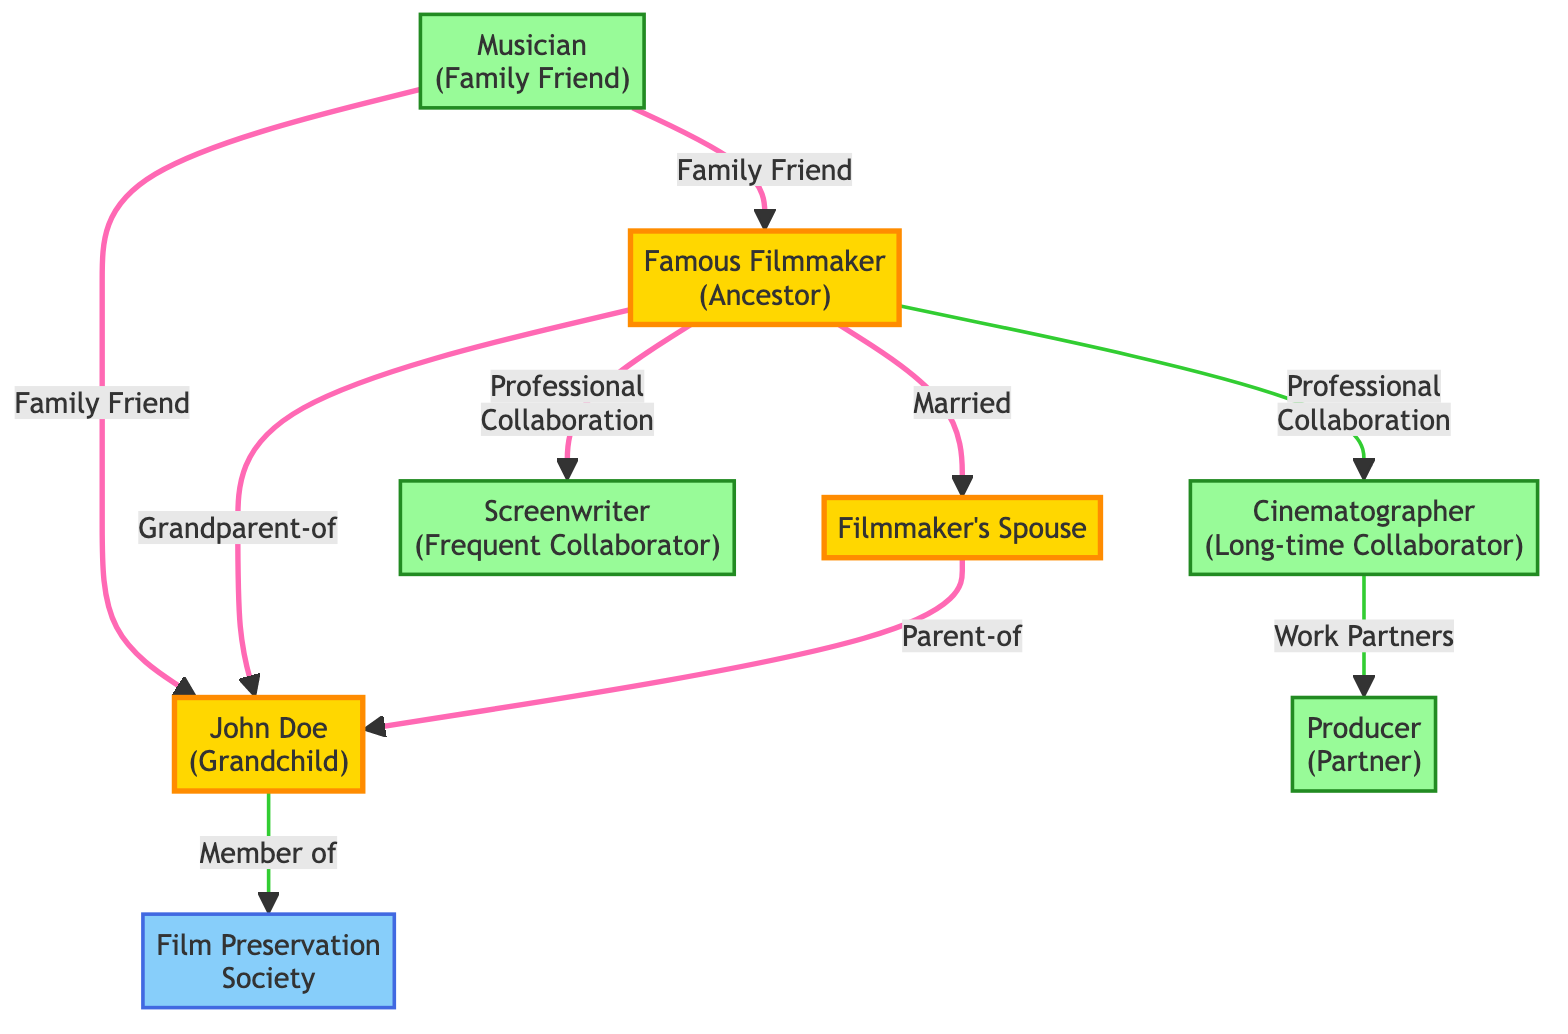What is the total number of nodes in the diagram? The diagram contains eight distinct entities or 'nodes' represented by circles, each representing a person or organization. To find the total, we count each one listed: Famous Filmmaker (Ancestor), John Doe (Grandchild), Filmmaker's Spouse, Cinematographer (Long-time Collaborator), Screenwriter (Frequent Collaborator), Musician (Family Friend), Producer (Partner), and Film Preservation Society. This gives a total of 8 nodes.
Answer: 8 Who is the grandparent of John Doe? The diagram indicates that the Famous Filmmaker (Ancestor) has a direct line represented by the edge labeled "Grandparent-of" leading to John Doe. Since the Famous Filmmaker is explicitly labeled as John's grandparent, we identify that as the answer.
Answer: Famous Filmmaker (Ancestor) What relationship does the Cinematographer have with the Producer? The edge connecting the Cinematographer and Producer is labeled "Work Partners," indicating a professional relationship between these two collaborators in the filmmaking industry. This means they collaborate professionally in the production of films.
Answer: Work Partners Which node does John Doe connect to labeled "Member of"? The diagram shows that the connection from John Doe leads to the Film Preservation Society with the edge labeled "Member of." This indicates that John is affiliated with this organization, reflecting his involvement or membership.
Answer: Film Preservation Society What is the total number of edges in the diagram? The edges, representing relationships between the nodes, include those between the Famous Filmmaker (Ancestor) and the Filmmaker's Spouse, that connect the Famous Filmmaker to both the Cinematographer and Screenwriter, among others. By counting all connections or edges displayed, we find there are a total of 8 edges in the network.
Answer: 8 How many family relationships are depicted in the diagram? To find the family relationships, we look for connections that are labeled parent-child or spousal connections. The edges "Married" and "Parent-of" connect nodes from the family. Counting these specific family relationships reveals there are a total of 3 edges that represent family ties (1 for marriage and 2 for parentage).
Answer: 3 What type of relationship exists between the Famous Filmmaker and the Screenwriter? The edge connecting the Famous Filmmaker and the Screenwriter is labeled "Professional Collaboration," which means there is a working relationship between these two entities in the industry of filmmaking, indicating that they have likely cooperated on films in a professional setting.
Answer: Professional Collaboration Who is the family friend of both John Doe and the Famous Filmmaker? The diagram has a connection from the Musician to both the Famous Filmmaker and John Doe, labeled "Family Friend." This indicates a personal, non-professional relationship shared between the Musician and both family members, showing they are friends despite any business connections.
Answer: Musician 